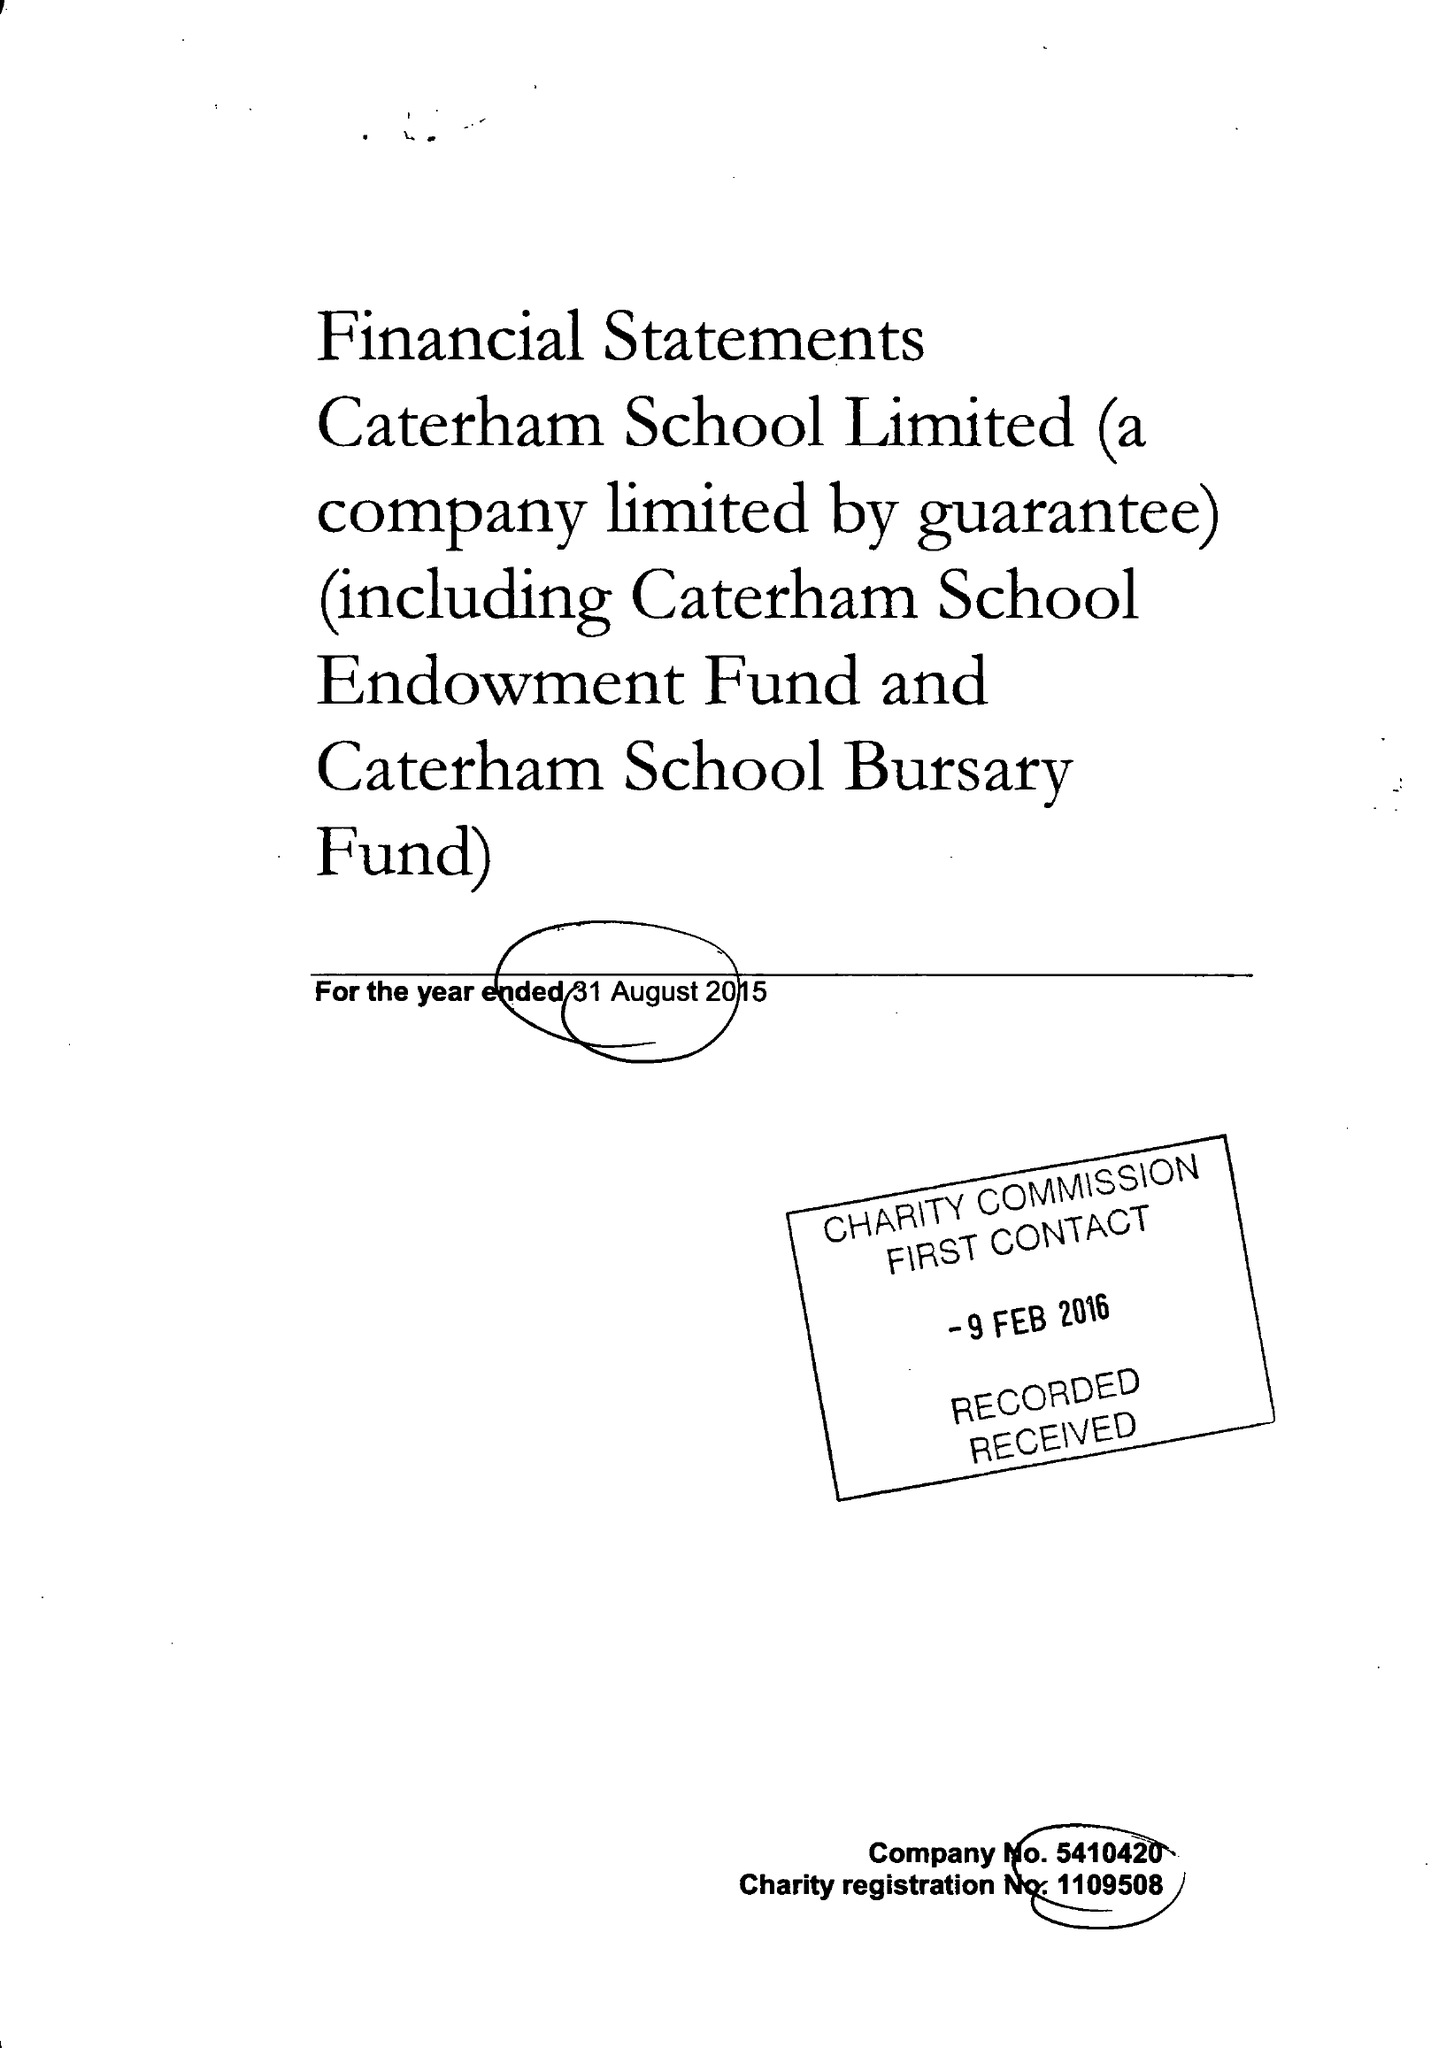What is the value for the report_date?
Answer the question using a single word or phrase. 2015-08-31 